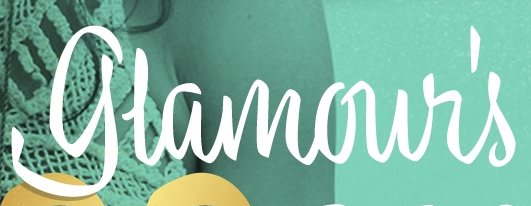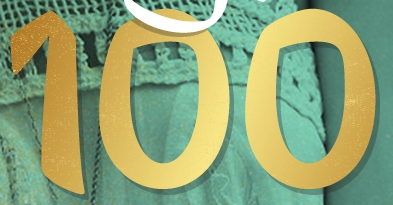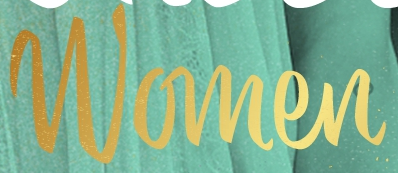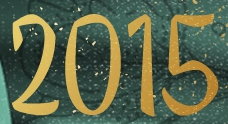What text appears in these images from left to right, separated by a semicolon? glamour's; 100; Women; 2015 